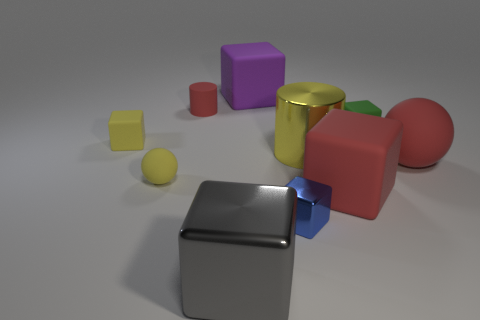Subtract 3 cubes. How many cubes are left? 3 Subtract all purple cubes. How many cubes are left? 5 Subtract all blue blocks. How many blocks are left? 5 Subtract all gray cubes. Subtract all green spheres. How many cubes are left? 5 Subtract all cubes. How many objects are left? 4 Add 9 red cylinders. How many red cylinders are left? 10 Add 9 tiny brown spheres. How many tiny brown spheres exist? 9 Subtract 0 blue cylinders. How many objects are left? 10 Subtract all yellow cylinders. Subtract all rubber balls. How many objects are left? 7 